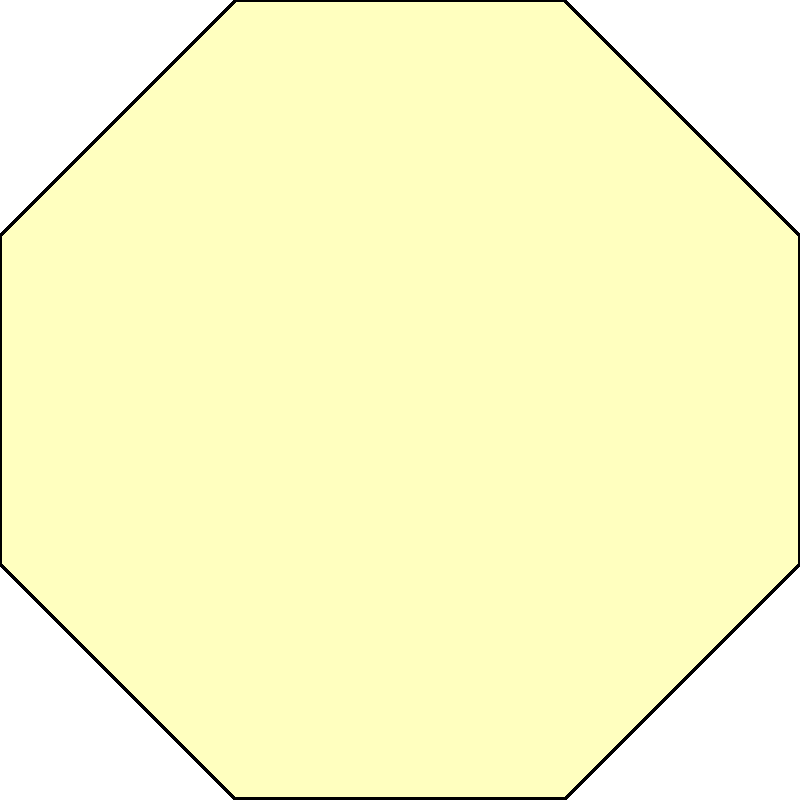In the sacred tessellation shown above, which combines octagonal and square shapes, what is the measure of the central angle of each octagon in degrees? To determine the central angle of each octagon in the tessellation, we can follow these steps:

1) First, recall that the sum of interior angles of an octagon is given by the formula:
   $$(n-2) \times 180°$$
   where n is the number of sides. For an octagon, n = 8.

2) Calculate the sum of interior angles:
   $$(8-2) \times 180° = 6 \times 180° = 1080°$$

3) In a regular octagon, all interior angles are equal. To find one interior angle, divide the sum by 8:
   $$1080° \div 8 = 135°$$

4) The central angle of a regular polygon is supplementary to its interior angle. This means they add up to 180°. So we can calculate:
   $$180° - 135° = 45°$$

5) Therefore, the central angle of each octagon in this tessellation is 45°.

This can also be visually confirmed in the diagram, where we can see that 8 octagons meet at the center, forming a full 360° rotation. Each octagon must contribute 1/8 of 360°, which is indeed 45°.
Answer: 45° 